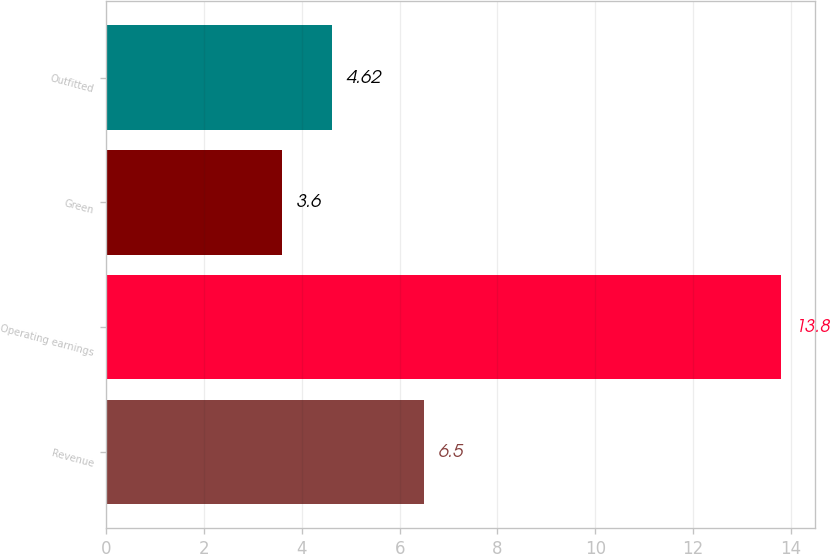<chart> <loc_0><loc_0><loc_500><loc_500><bar_chart><fcel>Revenue<fcel>Operating earnings<fcel>Green<fcel>Outfitted<nl><fcel>6.5<fcel>13.8<fcel>3.6<fcel>4.62<nl></chart> 